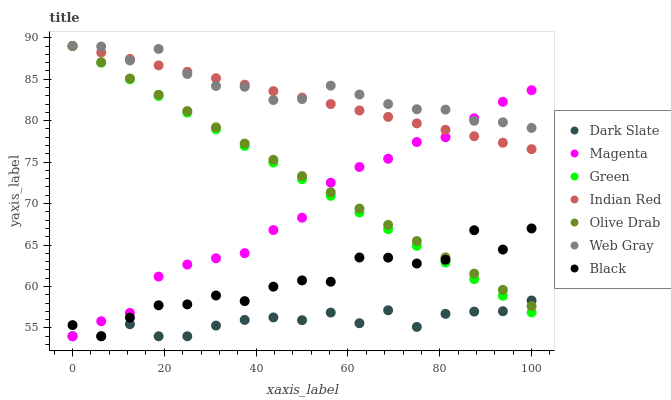Does Dark Slate have the minimum area under the curve?
Answer yes or no. Yes. Does Web Gray have the maximum area under the curve?
Answer yes or no. Yes. Does Green have the minimum area under the curve?
Answer yes or no. No. Does Green have the maximum area under the curve?
Answer yes or no. No. Is Olive Drab the smoothest?
Answer yes or no. Yes. Is Black the roughest?
Answer yes or no. Yes. Is Dark Slate the smoothest?
Answer yes or no. No. Is Dark Slate the roughest?
Answer yes or no. No. Does Dark Slate have the lowest value?
Answer yes or no. Yes. Does Green have the lowest value?
Answer yes or no. No. Does Olive Drab have the highest value?
Answer yes or no. Yes. Does Dark Slate have the highest value?
Answer yes or no. No. Is Black less than Web Gray?
Answer yes or no. Yes. Is Web Gray greater than Dark Slate?
Answer yes or no. Yes. Does Indian Red intersect Magenta?
Answer yes or no. Yes. Is Indian Red less than Magenta?
Answer yes or no. No. Is Indian Red greater than Magenta?
Answer yes or no. No. Does Black intersect Web Gray?
Answer yes or no. No. 